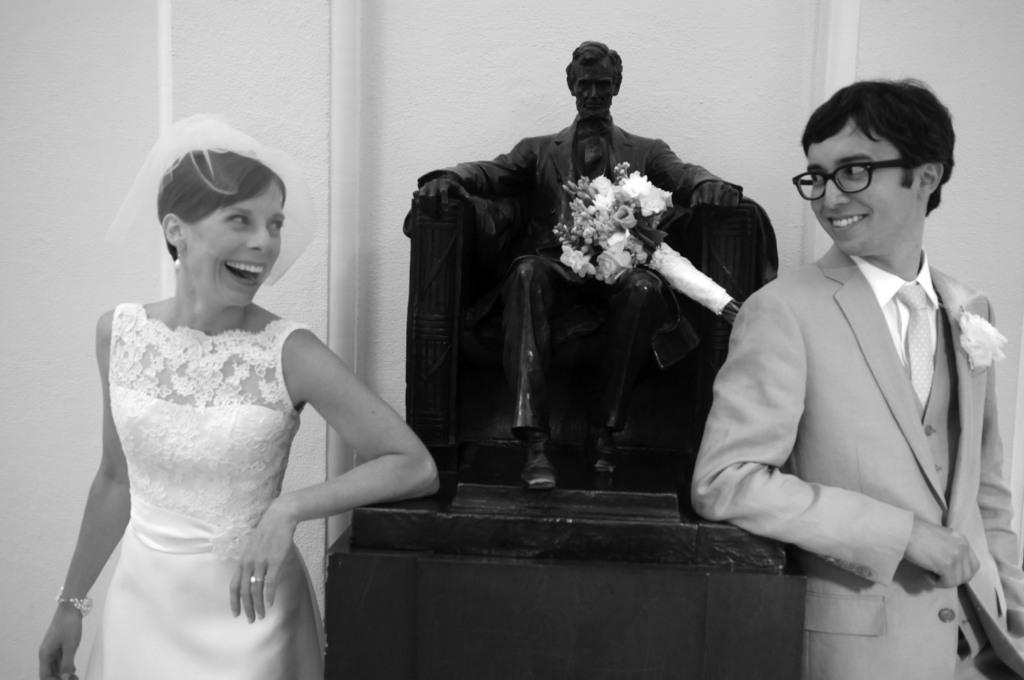What is the color scheme of the image? The image is black and white. How many people are in the image? There is a woman and a man in the image. What are the facial expressions of the people in the image? Both the woman and the man are smiling. Can you describe the man's appearance? The man is wearing spectacles. What can be seen in the background of the image? There is a sculpture, a flower bouquet, and a wall in the background of the image. Where is the home located in the image? There is no home present in the image. What type of discussion is taking place between the woman and the man in the image? There is no discussion taking place between the woman and the man in the image; they are simply smiling. 